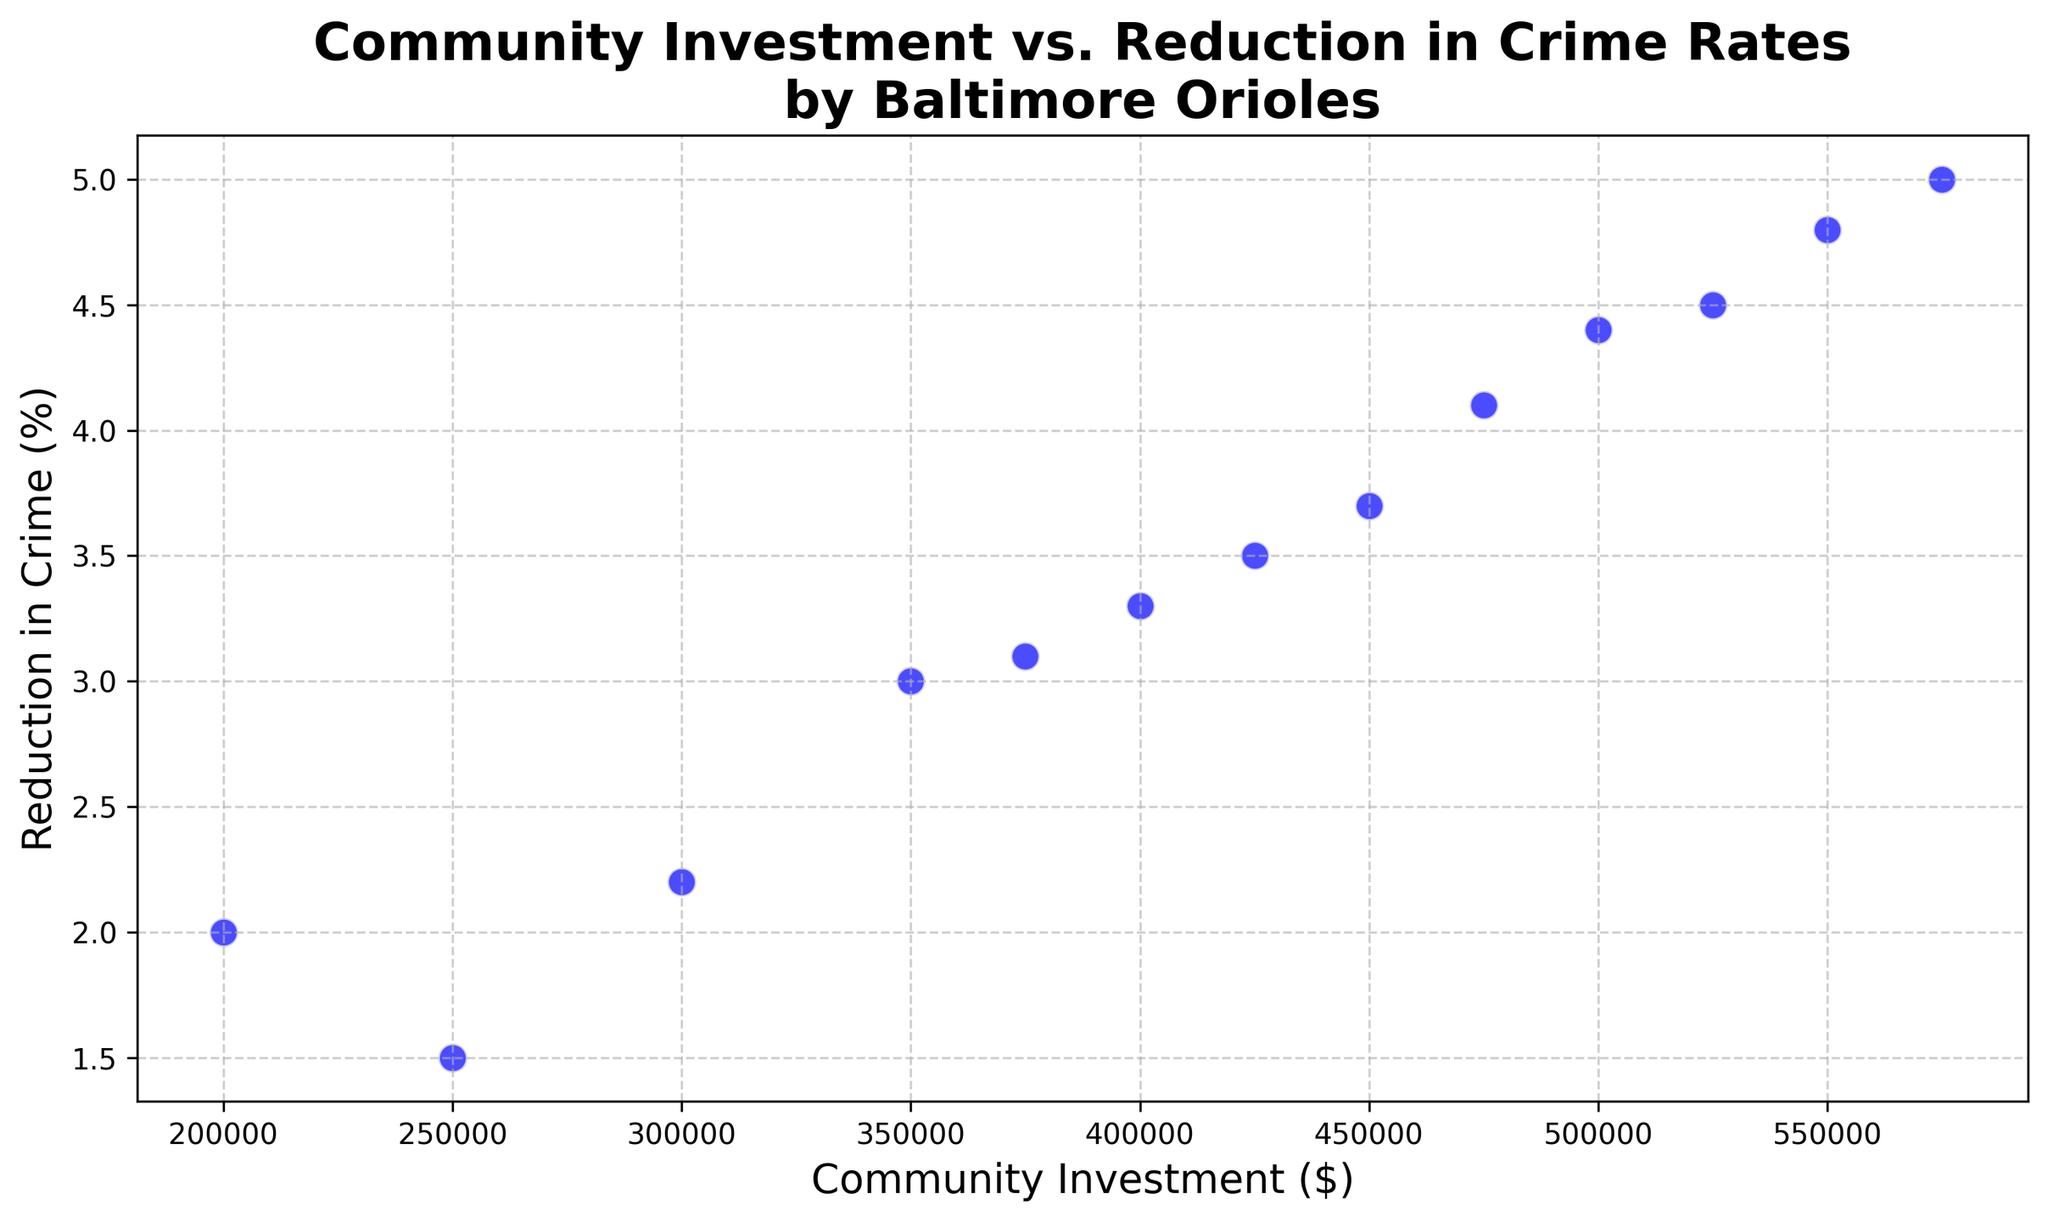What is the trend shown in the scatter plot? The scatter plot shows an upward trend, indicating that as community investment increases, the reduction in crime rates also increases. This suggests that higher investments by the Baltimore Orioles in community initiatives tend to correlate with greater reduction in crime rates in Baltimore neighborhoods.
Answer: Upward trend Which year had the highest community investment? Looking at the scatter plot, the rightmost point represents the year with the highest community investment, which is 2022 with a community investment of $575,000.
Answer: 2022 How does the reduction in crime in 2015 compare to 2012? In the scatter plot, the point for 2015 ($400,000) has a higher reduction in crime (3.3%) compared to 2012 ($300,000) which has a reduction in crime of 2.2%.
Answer: 2015 shows a higher reduction What is the average reduction in crime for the years 2010 and 2022? The reductions for 2010 and 2022 are 2% and 5%, respectively. Adding them (2 + 5) and dividing by 2 to find the average: (2 + 5) / 2 = 3.5%
Answer: 3.5% By how much did the community investment increase from 2010 to 2022? The community investment in 2010 was $200,000 and in 2022 it was $575,000. The increase is calculated by subtracting the two values: $575,000 - $200,000 = $375,000.
Answer: $375,000 Which data point represents the year with the least reduction in crime and what was the community investment for that year? The year with the least reduction in crime is 2011, at 1.5%. The corresponding community investment was $250,000.
Answer: 2011, $250,000 If community investment were $600,000, what could be the expected reduction in crime, based on the trend shown? Based on the upward trend visible in the scatter plot, it is reasonable to estimate an expected reduction greater than 5%, since $575,000 corresponds to a 5% reduction. Extrapolating slightly higher would predict around 5.3% or more.
Answer: Around 5.3% or more What is the total community investment from 2010 to 2022 inclusive? Summing up all the community investments from each year between 2010 and 2022 inclusive: 200000 + 250000 + 300000 + 350000 + 375000 + 400000 + 425000 + 450000 + 475000 + 500000 + 525000 + 550000 + 575000 = $5,375,000.
Answer: $5,375,000 How did the community investment in 2016 compare to the reduction in crime for that year? For 2016, the community investment was $425,000 and the reduction in crime was 3.5%. This follows the trend where increased investment correlates with greater reduction in crime.
Answer: $425,000 investment, 3.5% reduction Using the scatter plot, what would you infer about the potential impact of doubling the investment from 2012? In 2012, the investment was $300,000 with a crime reduction of 2.2%. Doubling the investment to $600,000 could potentially yield more than double the reduction, extrapolating the trend—estimating around 5.3% reduction—similar to the expected value noted earlier.
Answer: Potential 5.3% reduction 